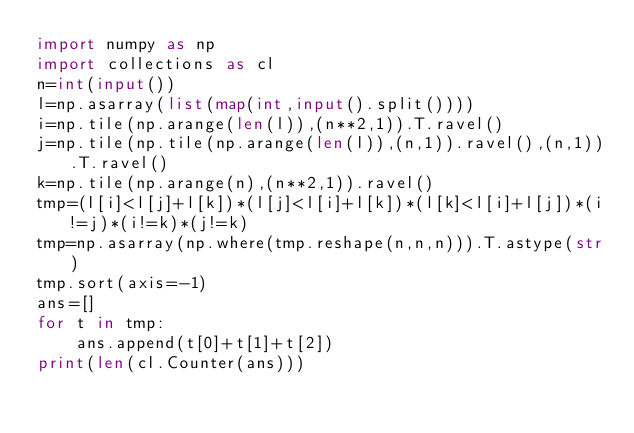Convert code to text. <code><loc_0><loc_0><loc_500><loc_500><_Python_>import numpy as np
import collections as cl
n=int(input())
l=np.asarray(list(map(int,input().split())))
i=np.tile(np.arange(len(l)),(n**2,1)).T.ravel()
j=np.tile(np.tile(np.arange(len(l)),(n,1)).ravel(),(n,1)).T.ravel()
k=np.tile(np.arange(n),(n**2,1)).ravel()
tmp=(l[i]<l[j]+l[k])*(l[j]<l[i]+l[k])*(l[k]<l[i]+l[j])*(i!=j)*(i!=k)*(j!=k)
tmp=np.asarray(np.where(tmp.reshape(n,n,n))).T.astype(str)
tmp.sort(axis=-1)
ans=[]
for t in tmp:
    ans.append(t[0]+t[1]+t[2])
print(len(cl.Counter(ans)))</code> 